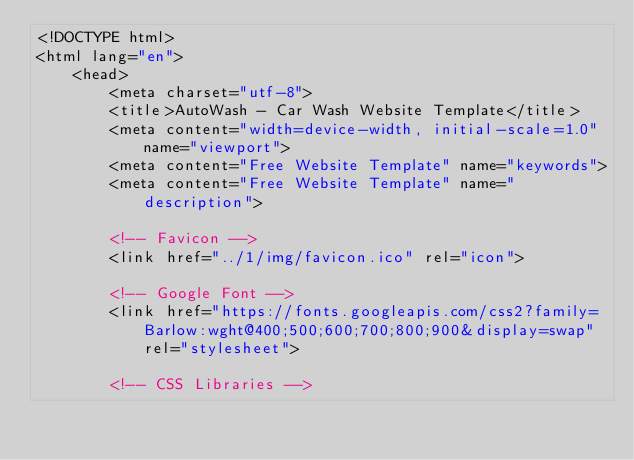<code> <loc_0><loc_0><loc_500><loc_500><_HTML_><!DOCTYPE html>
<html lang="en">
    <head>
        <meta charset="utf-8">
        <title>AutoWash - Car Wash Website Template</title>
        <meta content="width=device-width, initial-scale=1.0" name="viewport">
        <meta content="Free Website Template" name="keywords">
        <meta content="Free Website Template" name="description">

        <!-- Favicon -->
        <link href="../1/img/favicon.ico" rel="icon">

        <!-- Google Font -->
        <link href="https://fonts.googleapis.com/css2?family=Barlow:wght@400;500;600;700;800;900&display=swap" rel="stylesheet"> 
        
        <!-- CSS Libraries --></code> 